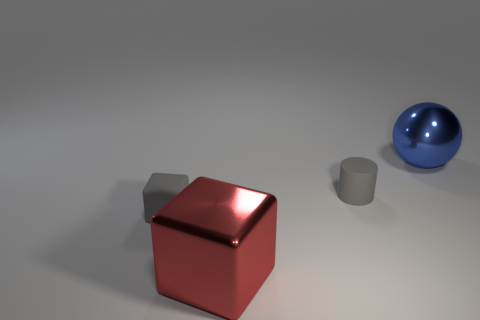Are there fewer tiny rubber cubes that are to the right of the small gray rubber cylinder than metallic things that are to the right of the big block?
Your response must be concise. Yes. What number of other things are there of the same size as the red metallic thing?
Provide a short and direct response. 1. Is the blue sphere made of the same material as the large thing in front of the tiny gray rubber block?
Offer a terse response. Yes. What number of objects are either matte objects that are on the right side of the large red metal block or gray rubber objects that are on the right side of the small gray matte block?
Offer a very short reply. 1. What color is the tiny cylinder?
Offer a very short reply. Gray. Are there fewer tiny rubber blocks that are on the right side of the large red block than large gray cylinders?
Keep it short and to the point. No. Is there anything else that is the same shape as the red thing?
Your answer should be compact. Yes. Are there any gray rubber cubes?
Keep it short and to the point. Yes. Is the number of shiny blocks less than the number of large brown matte blocks?
Make the answer very short. No. What number of other gray cubes have the same material as the big block?
Ensure brevity in your answer.  0. 